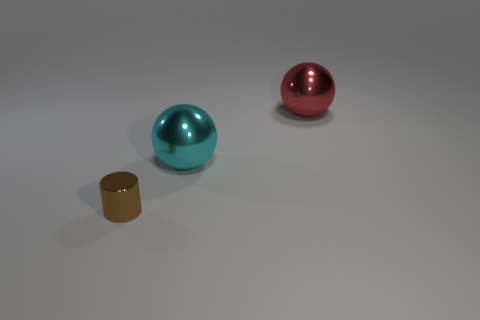Are there any other things that have the same size as the brown metal cylinder?
Provide a short and direct response. No. There is a thing that is left of the big red metallic thing and behind the brown thing; what shape is it?
Your answer should be very brief. Sphere. Are there any other tiny objects that have the same color as the tiny object?
Your answer should be very brief. No. Are any brown shiny things visible?
Your response must be concise. Yes. There is a thing that is left of the cyan metallic ball; what is its color?
Keep it short and to the point. Brown. There is a cyan metal ball; is its size the same as the shiny sphere that is on the right side of the large cyan object?
Your response must be concise. Yes. Are there any tiny brown things made of the same material as the big cyan object?
Give a very brief answer. Yes. There is a big cyan metallic thing; what shape is it?
Keep it short and to the point. Sphere. Do the red metal thing and the cyan sphere have the same size?
Your answer should be very brief. Yes. What number of other things are the same shape as the brown object?
Provide a succinct answer. 0. 